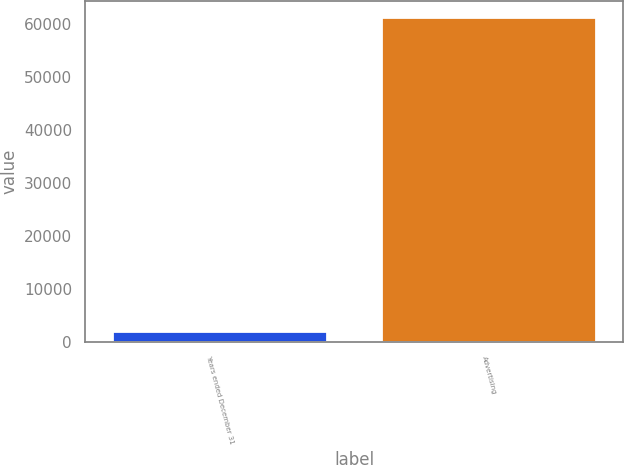Convert chart. <chart><loc_0><loc_0><loc_500><loc_500><bar_chart><fcel>Years ended December 31<fcel>Advertising<nl><fcel>2016<fcel>61258<nl></chart> 